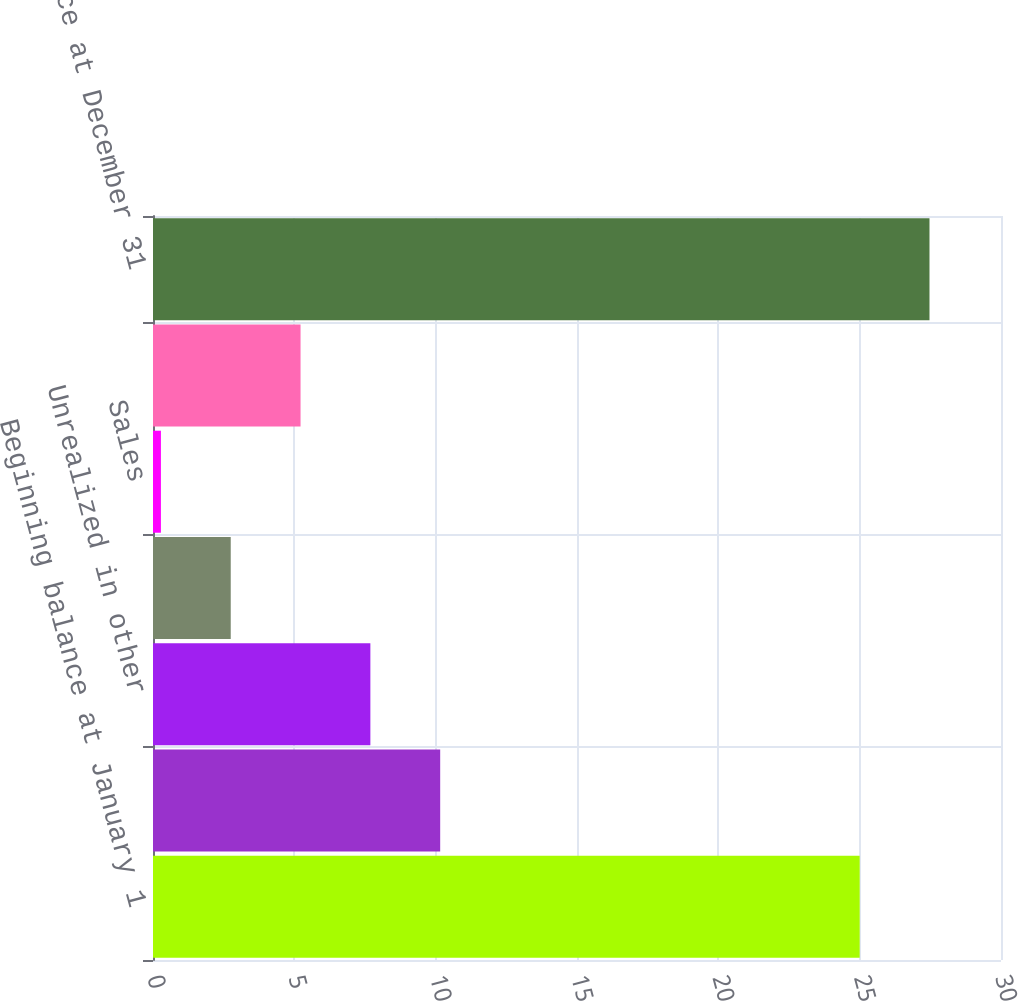Convert chart. <chart><loc_0><loc_0><loc_500><loc_500><bar_chart><fcel>Beginning balance at January 1<fcel>Realized in earnings<fcel>Unrealized in other<fcel>Purchases<fcel>Sales<fcel>Settlements<fcel>Balance at December 31<nl><fcel>25<fcel>10.16<fcel>7.69<fcel>2.75<fcel>0.28<fcel>5.22<fcel>27.47<nl></chart> 